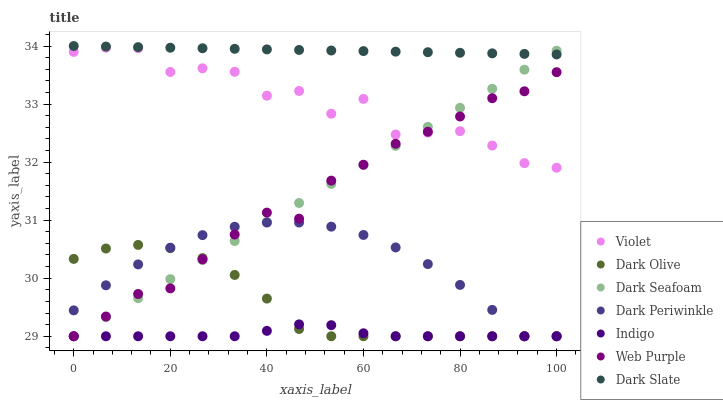Does Indigo have the minimum area under the curve?
Answer yes or no. Yes. Does Dark Slate have the maximum area under the curve?
Answer yes or no. Yes. Does Dark Olive have the minimum area under the curve?
Answer yes or no. No. Does Dark Olive have the maximum area under the curve?
Answer yes or no. No. Is Dark Seafoam the smoothest?
Answer yes or no. Yes. Is Violet the roughest?
Answer yes or no. Yes. Is Dark Olive the smoothest?
Answer yes or no. No. Is Dark Olive the roughest?
Answer yes or no. No. Does Indigo have the lowest value?
Answer yes or no. Yes. Does Dark Slate have the lowest value?
Answer yes or no. No. Does Dark Slate have the highest value?
Answer yes or no. Yes. Does Dark Olive have the highest value?
Answer yes or no. No. Is Violet less than Dark Slate?
Answer yes or no. Yes. Is Dark Slate greater than Dark Olive?
Answer yes or no. Yes. Does Dark Periwinkle intersect Web Purple?
Answer yes or no. Yes. Is Dark Periwinkle less than Web Purple?
Answer yes or no. No. Is Dark Periwinkle greater than Web Purple?
Answer yes or no. No. Does Violet intersect Dark Slate?
Answer yes or no. No. 